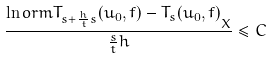<formula> <loc_0><loc_0><loc_500><loc_500>\frac { \ln o r m { T _ { s + \frac { h } { t } s } ( u _ { 0 } , f ) - T _ { s } ( u _ { 0 } , f ) } _ { X } } { \frac { s } { t } h } \leq C</formula> 